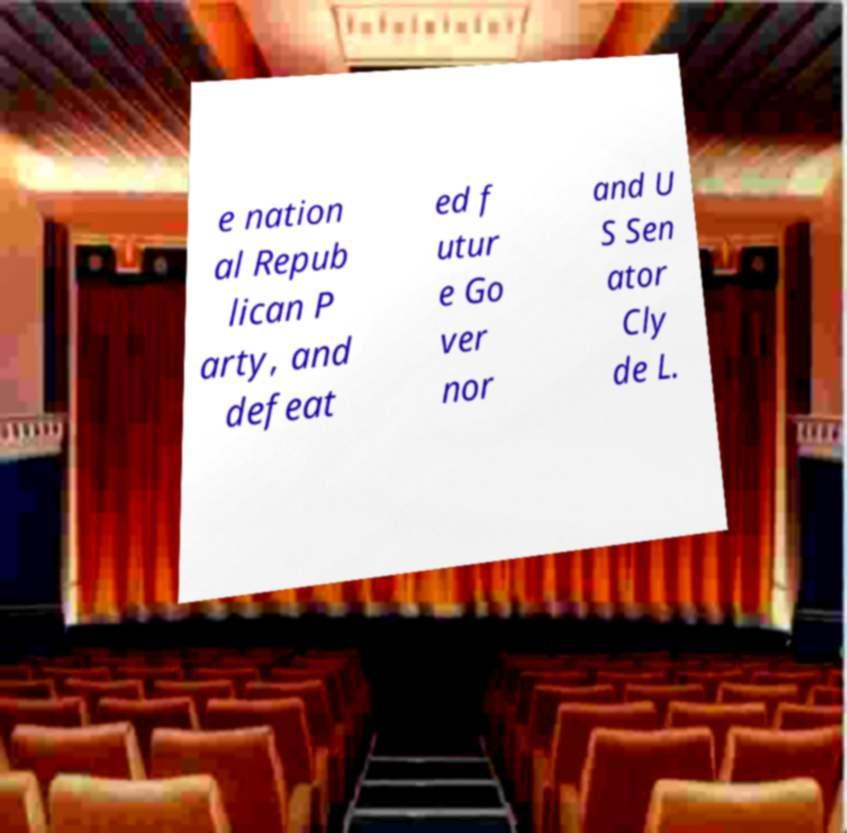What messages or text are displayed in this image? I need them in a readable, typed format. e nation al Repub lican P arty, and defeat ed f utur e Go ver nor and U S Sen ator Cly de L. 